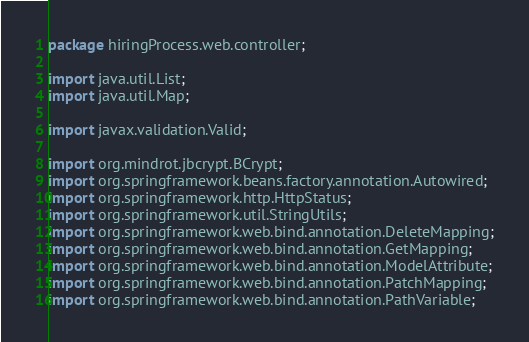Convert code to text. <code><loc_0><loc_0><loc_500><loc_500><_Java_>package hiringProcess.web.controller;

import java.util.List;
import java.util.Map;

import javax.validation.Valid;

import org.mindrot.jbcrypt.BCrypt;
import org.springframework.beans.factory.annotation.Autowired;
import org.springframework.http.HttpStatus;
import org.springframework.util.StringUtils;
import org.springframework.web.bind.annotation.DeleteMapping;
import org.springframework.web.bind.annotation.GetMapping;
import org.springframework.web.bind.annotation.ModelAttribute;
import org.springframework.web.bind.annotation.PatchMapping;
import org.springframework.web.bind.annotation.PathVariable;</code> 